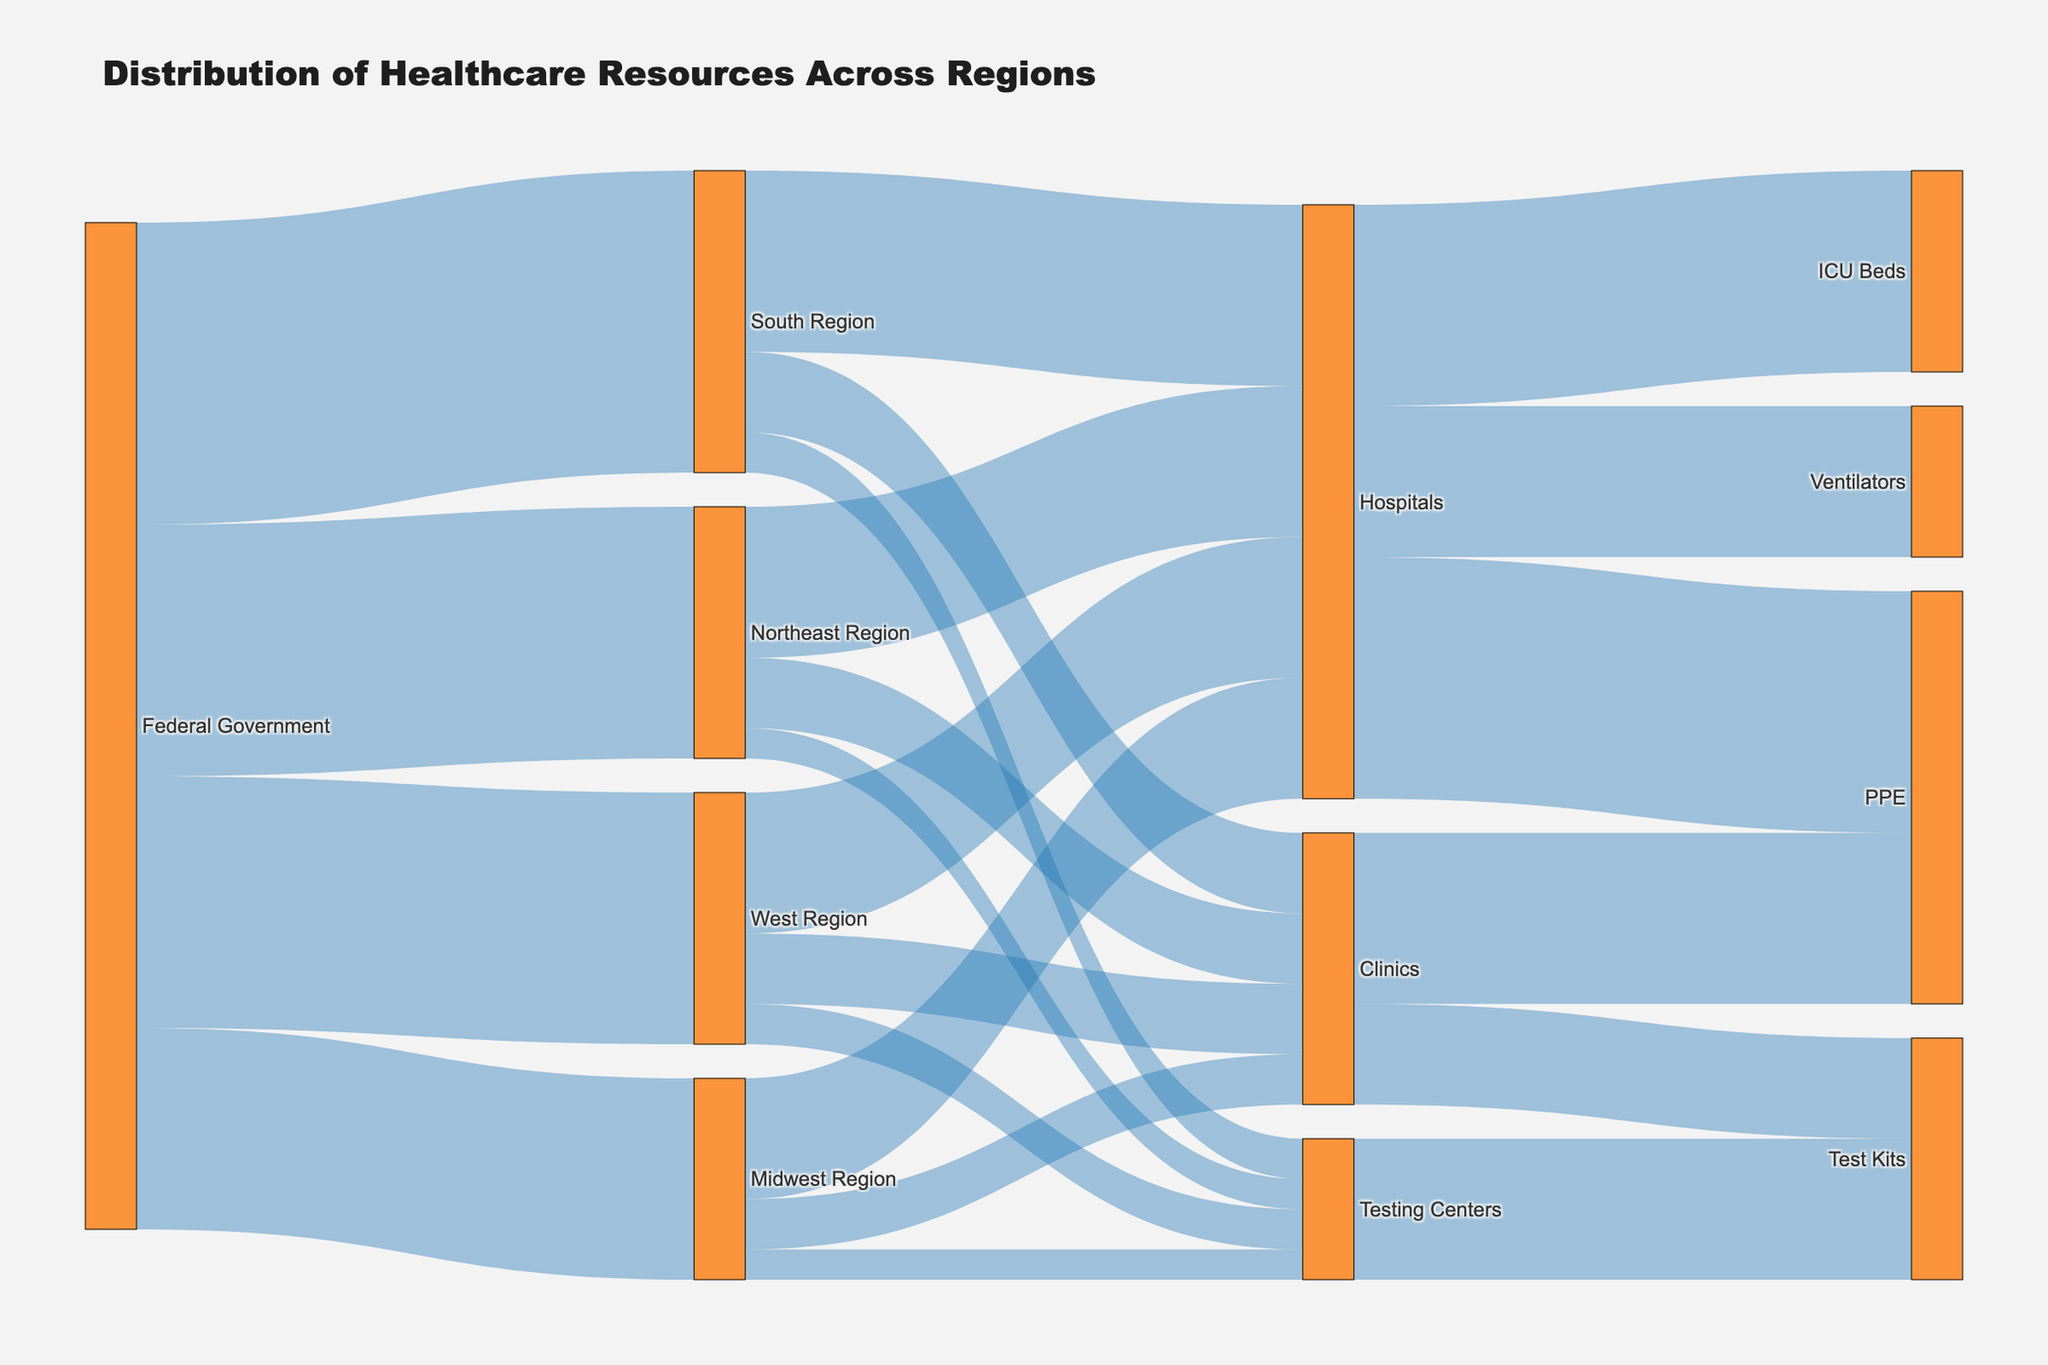What is the title of the Sankey diagram? The title is typically displayed at the top of the figure and provides a summary of what the diagram represents.
Answer: Distribution of Healthcare Resources Across Regions How many regions receive resources from the Federal Government? There are four regions that are targets connected to the source "Federal Government" in the Sankey diagram. These regions are indicated by the flow lines.
Answer: Four regions Which destination receives the highest value of resources from the Northeast Region? By examining the width of the flow lines from the Northeast Region, we identify the one with the largest value, which flows to Hospitals.
Answer: Hospitals How much total resource value is distributed to the West Region? Summing the values of resources flowing into the West Region from the Federal Government will give the total: 2500.
Answer: 2500 Compare the total resource values allocated to Clinics in the Northeast Region and the Midwest Region. Which is higher? By summing the values of the respective flows, we see Northeast Region allocates 700 to Clinics and Midwest Region allocates 500. 700 is higher than 500.
Answer: Northeast Region How many types of resources are distributed to Hospitals? By counting the outgoing flow lines from Hospitals, we identify three distinct types of resources: ICU Beds, Ventilators, and PPE.
Answer: Three types What is the total value of Test Kits in the Sankey diagram? The values of Test Kits distributed to Clinics and Testing Centers represent the total. By adding (1000 + 1400), the total is 2400.
Answer: 2400 Which region allocates the highest value of resources to Testing Centers? By comparing the flows from each region to Testing Centers, we find the South Region allocates the highest value at 400.
Answer: South Region Which type of healthcare facility receives the least resources from the Midwest Region? By comparing the values of resources flowing from the Midwest Region, Testing Centers receive the least with a value of 300.
Answer: Testing Centers Which resource type receives the highest total value across all sources? By summing the values for each resource type (ICU Beds, Ventilators, PPE, Test Kits) from all sources, PPE has the highest total (2400 from Hospitals + 1700 from Clinics = 4100).
Answer: PPE 